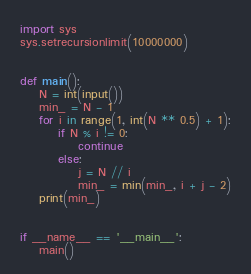<code> <loc_0><loc_0><loc_500><loc_500><_Python_>import sys
sys.setrecursionlimit(10000000)


def main():
    N = int(input())
    min_ = N - 1
    for i in range(1, int(N ** 0.5) + 1):
        if N % i != 0:
            continue
        else:
            j = N // i
            min_ = min(min_, i + j - 2)
    print(min_)


if __name__ == '__main__':
    main()
</code> 